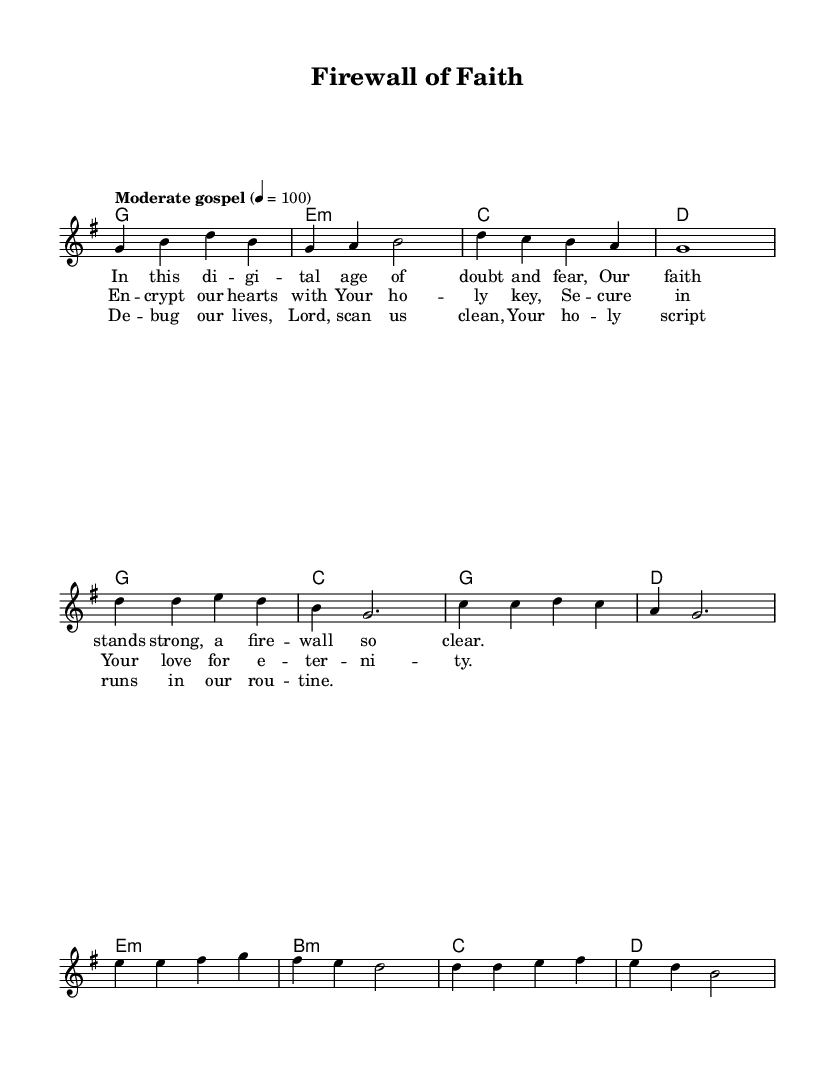What is the key signature of this music? The key signature is G major, which has one sharp, F sharp. This can be identified in the global section of the code where it is stated as \key g \major.
Answer: G major What is the time signature of this music? The time signature is 4/4, indicating there are four beats in each measure and the quarter note gets one beat. This is also noted in the global section of the code \time 4/4.
Answer: 4/4 What is the tempo marking of this music? The tempo marking is "Moderate gospel" with a BPM of 100, indicated by the line \tempo "Moderate gospel" 4 = 100 in the global section.
Answer: Moderate gospel, 100 How many measures are in the chorus section? The chorus consists of four measures, as counted in the melody section with the respective notes grouped accordingly. Each line within the chorus section contributes one measure, totaling four.
Answer: 4 What is the main theme of the lyrics in the verse? The main theme of the verse centers around faith in a digital age, highlighting the strength of faith amidst doubt and fear. This can be deduced from analyzing the lyrical content in the verseOne section.
Answer: Faith in a digital age Which musical element signifies a change in dynamics in the bridge? The bridge contains a lyrical plea for cleansing, akin to debugging, indicating a shift in emotional and musical dynamics. This thematic content suggests a more introspective level of engagement compared to the earlier sections.
Answer: Debugging and searching for cleansing 